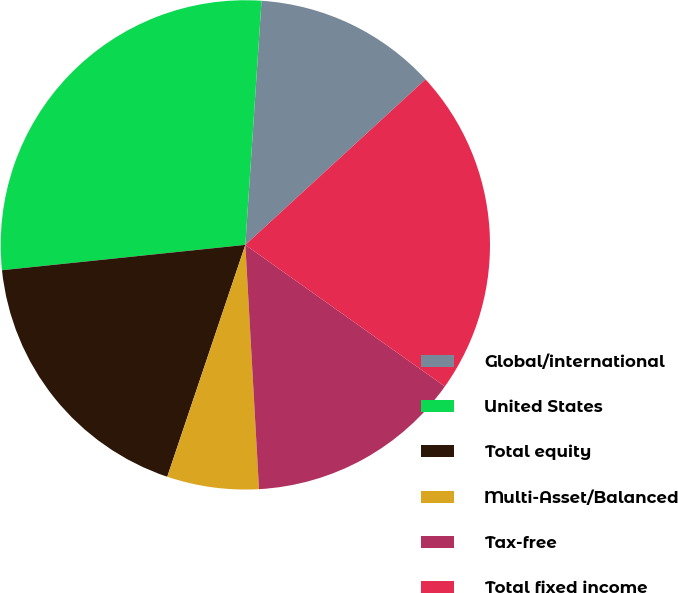<chart> <loc_0><loc_0><loc_500><loc_500><pie_chart><fcel>Global/international<fcel>United States<fcel>Total equity<fcel>Multi-Asset/Balanced<fcel>Tax-free<fcel>Total fixed income<nl><fcel>12.12%<fcel>27.71%<fcel>18.18%<fcel>6.06%<fcel>14.29%<fcel>21.65%<nl></chart> 